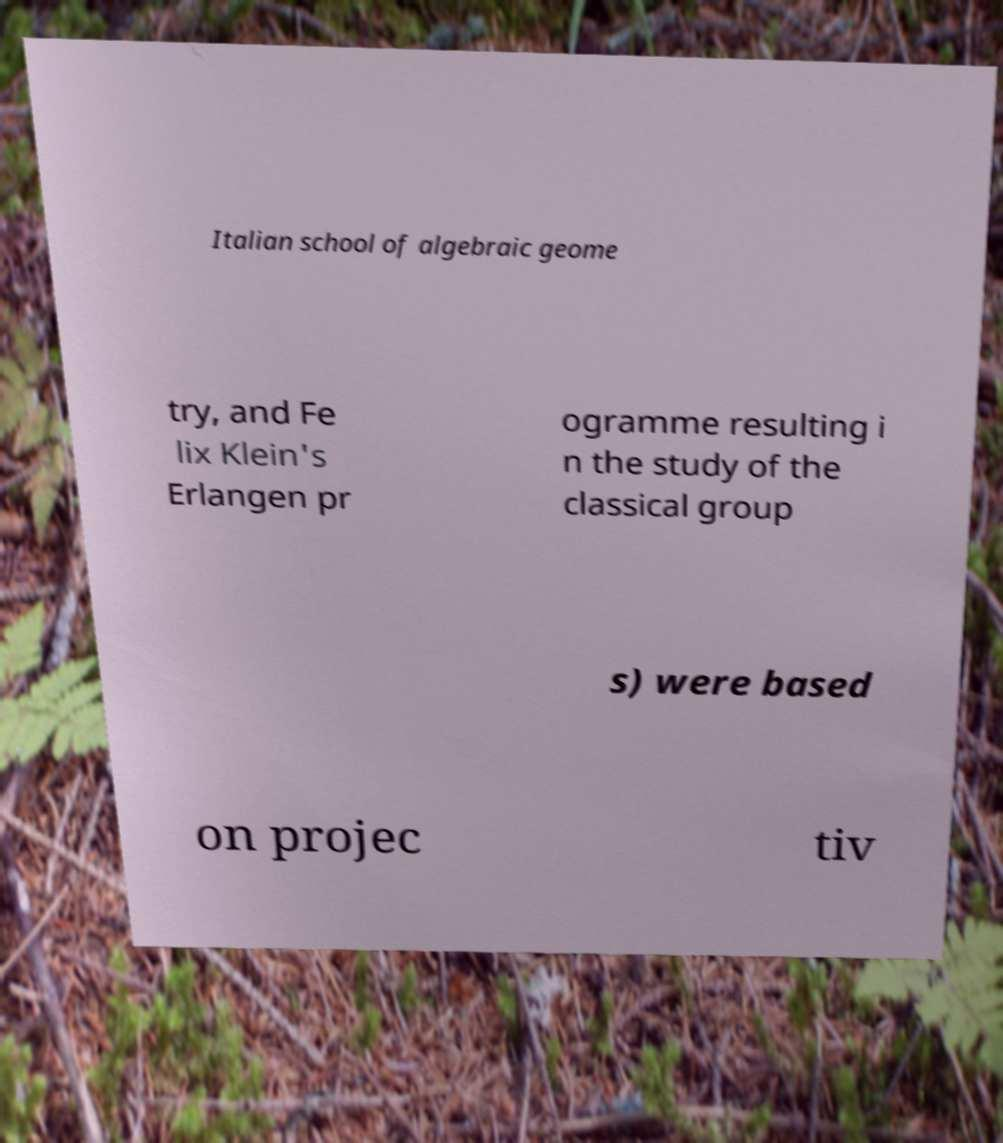Please read and relay the text visible in this image. What does it say? Italian school of algebraic geome try, and Fe lix Klein's Erlangen pr ogramme resulting i n the study of the classical group s) were based on projec tiv 